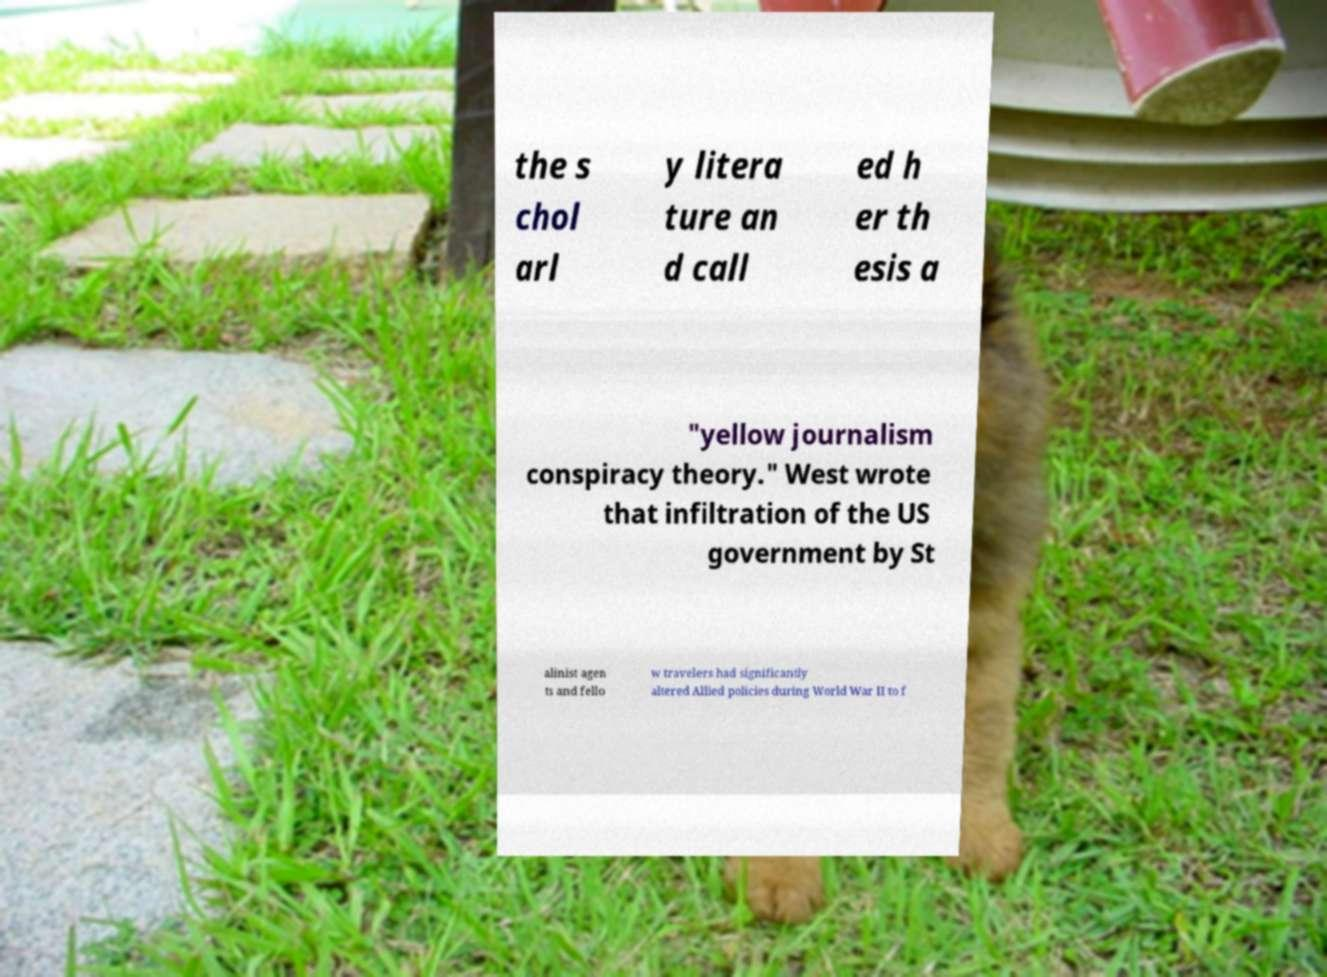I need the written content from this picture converted into text. Can you do that? the s chol arl y litera ture an d call ed h er th esis a "yellow journalism conspiracy theory." West wrote that infiltration of the US government by St alinist agen ts and fello w travelers had significantly altered Allied policies during World War II to f 